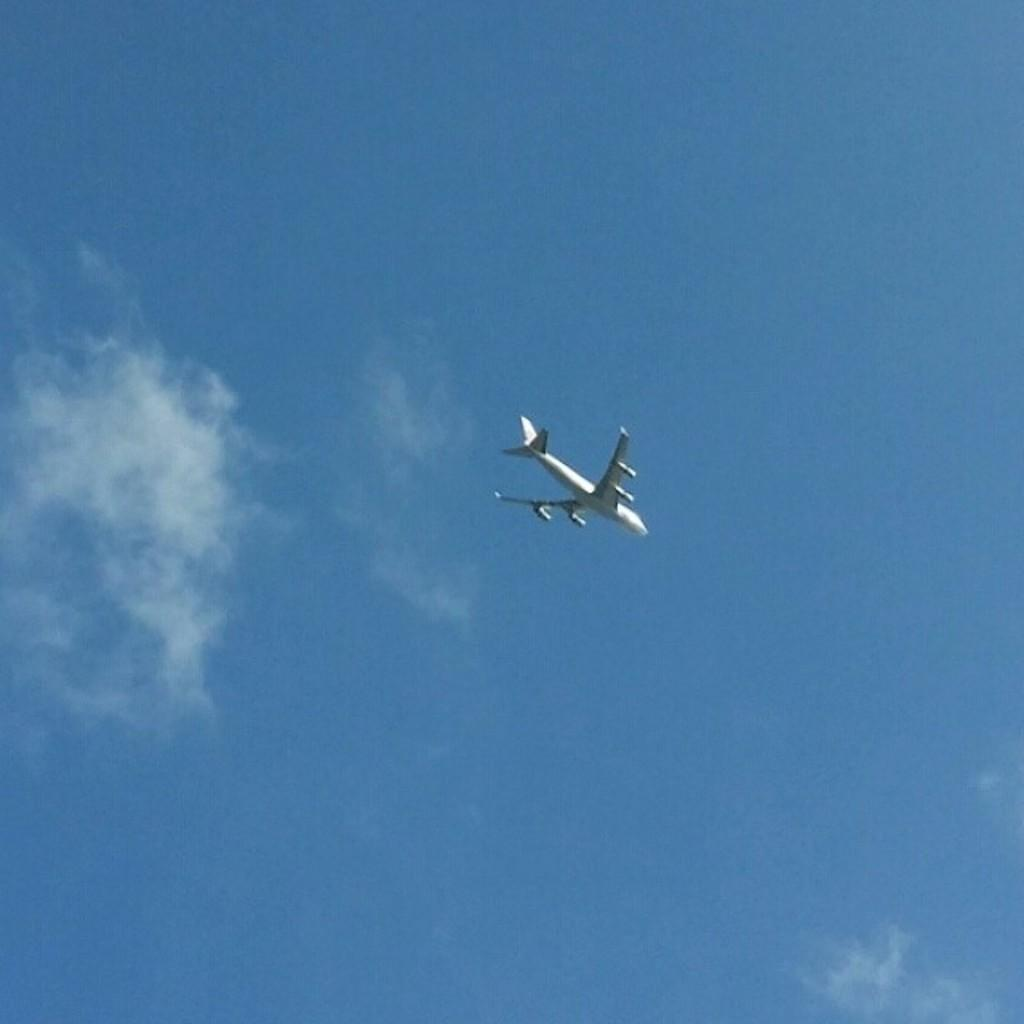What color is the airplane in the image? The airplane is white in the image. What is the airplane doing in the image? The airplane is flying in the air. What can be seen in the background of the image? There are clouds in the background of the image. What color is the sky in the image? The sky is blue in the image. Are there any giants visible in the image? No, there are no giants present in the image. What type of produce can be seen growing in the image? There is no produce visible in the image; it features an airplane flying in the sky. 